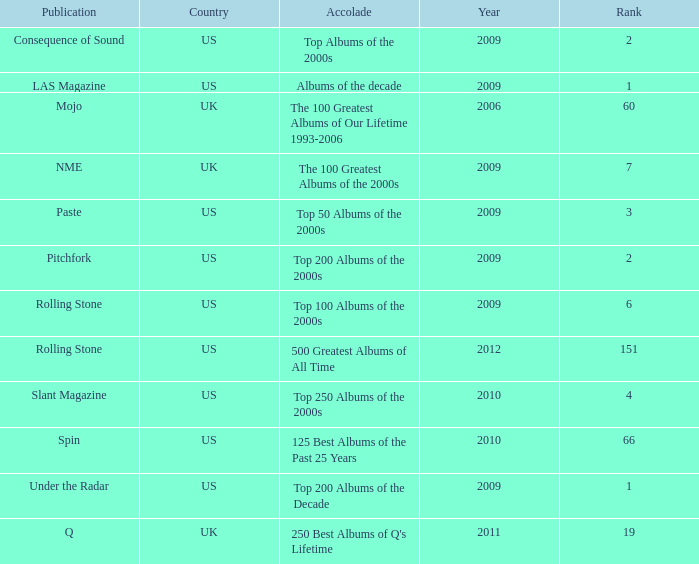In the list of top 125 best albums of the past 25 years after 2009, which album held the lowest rank? 66.0. 